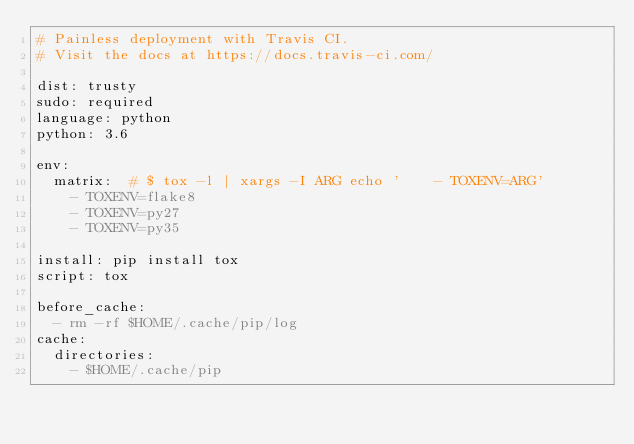<code> <loc_0><loc_0><loc_500><loc_500><_YAML_># Painless deployment with Travis CI.
# Visit the docs at https://docs.travis-ci.com/

dist: trusty
sudo: required
language: python
python: 3.6

env:
  matrix:  # $ tox -l | xargs -I ARG echo '    - TOXENV=ARG'
    - TOXENV=flake8
    - TOXENV=py27
    - TOXENV=py35

install: pip install tox
script: tox

before_cache:
  - rm -rf $HOME/.cache/pip/log
cache:
  directories:
    - $HOME/.cache/pip
</code> 